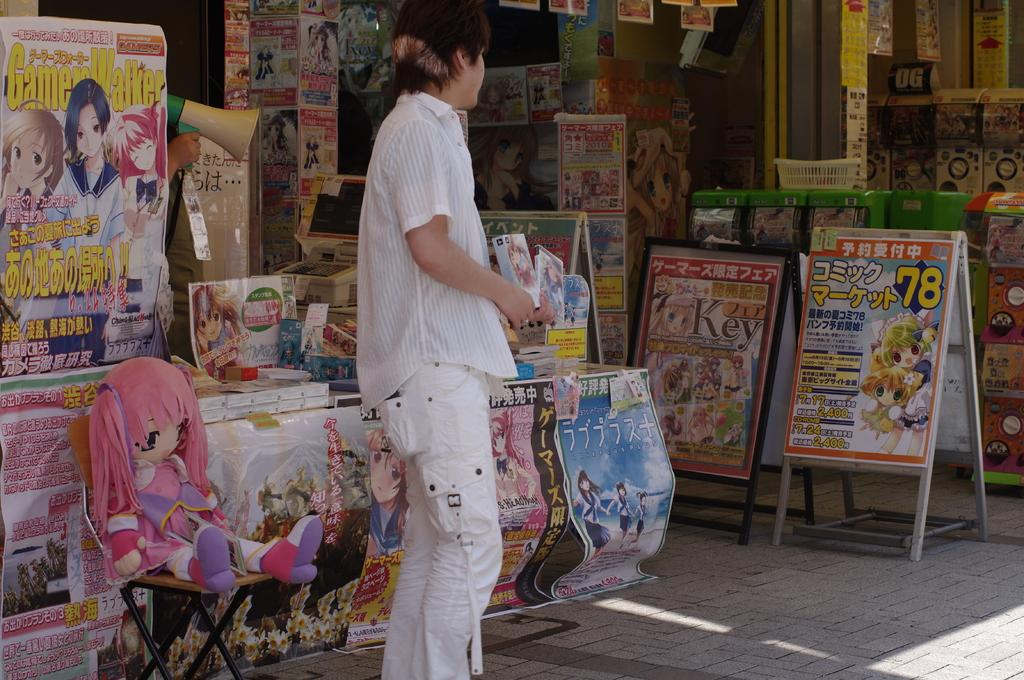Provide a one-sentence caption for the provided image. A store that sells goods based on animations and has foreign writing. 